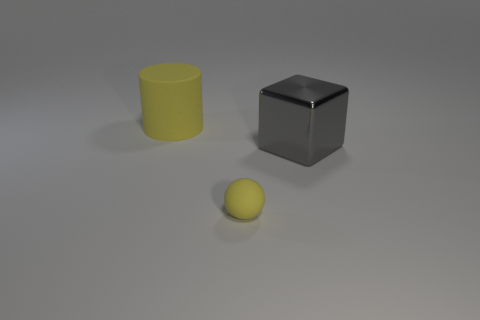Add 2 cyan metal balls. How many objects exist? 5 Subtract all blocks. How many objects are left? 2 Add 1 tiny purple things. How many tiny purple things exist? 1 Subtract 0 purple balls. How many objects are left? 3 Subtract all yellow rubber cylinders. Subtract all yellow matte objects. How many objects are left? 0 Add 3 large rubber cylinders. How many large rubber cylinders are left? 4 